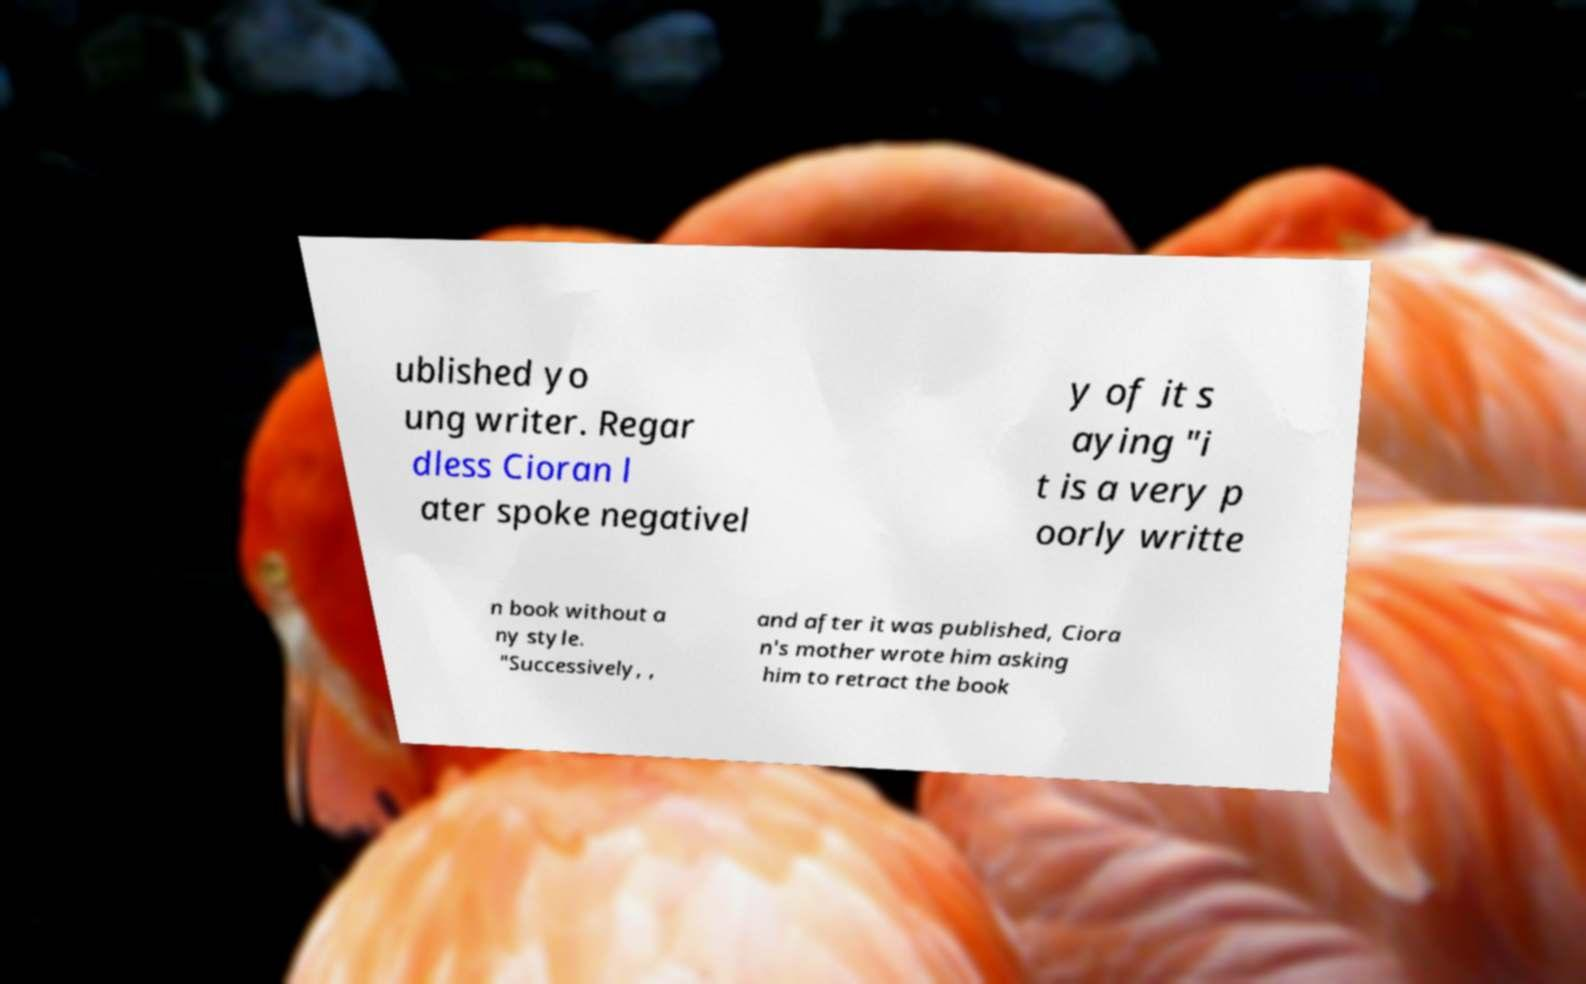I need the written content from this picture converted into text. Can you do that? ublished yo ung writer. Regar dless Cioran l ater spoke negativel y of it s aying "i t is a very p oorly writte n book without a ny style. "Successively, , and after it was published, Ciora n's mother wrote him asking him to retract the book 